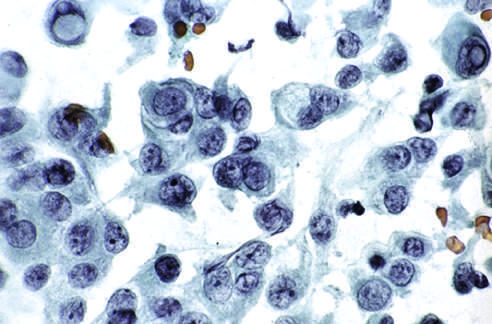re cells obtained by fine-needle aspiration of a papillary carcinoma?
Answer the question using a single word or phrase. Yes 